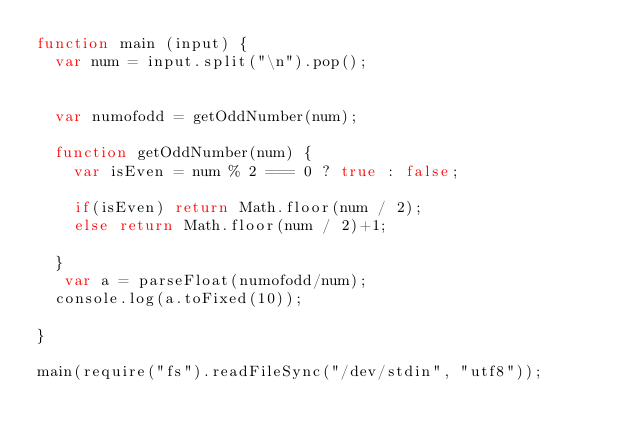Convert code to text. <code><loc_0><loc_0><loc_500><loc_500><_JavaScript_>function main (input) {
  var num = input.split("\n").pop();
  
  
  var numofodd = getOddNumber(num);
      
  function getOddNumber(num) {
  	var isEven = num % 2 === 0 ? true : false;
	
    if(isEven) return Math.floor(num / 2);
    else return Math.floor(num / 2)+1;
    
  }
   var a = parseFloat(numofodd/num);
  console.log(a.toFixed(10));

}

main(require("fs").readFileSync("/dev/stdin", "utf8"));</code> 